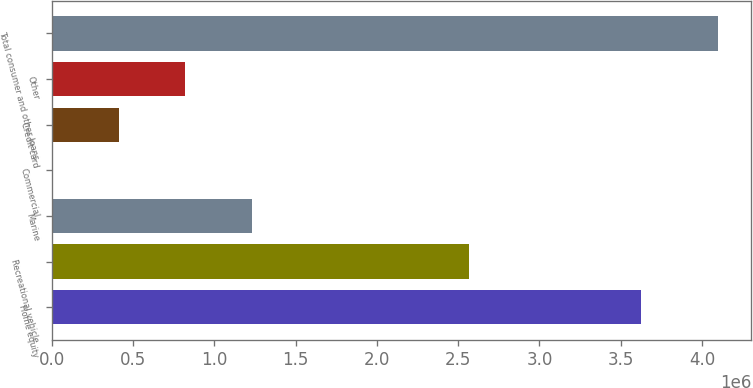Convert chart. <chart><loc_0><loc_0><loc_500><loc_500><bar_chart><fcel>Home equity<fcel>Recreational vehicle<fcel>Marine<fcel>Commercial<fcel>Credit card<fcel>Other<fcel>Total consumer and other loans<nl><fcel>3.62184e+06<fcel>2.56789e+06<fcel>1.23153e+06<fcel>3012<fcel>412518<fcel>822023<fcel>4.09807e+06<nl></chart> 